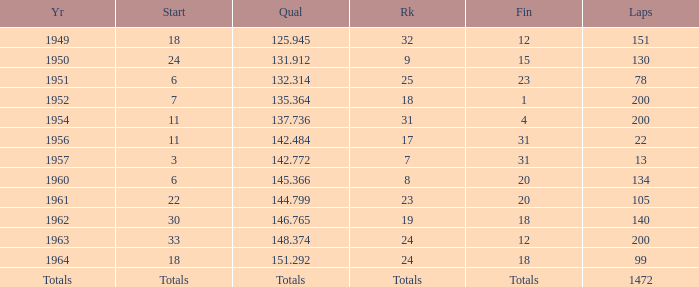Name the rank for 151 Laps 32.0. 